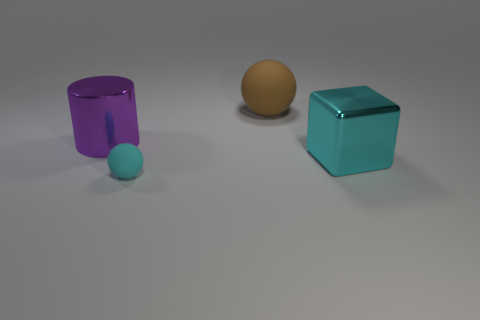Subtract all cylinders. How many objects are left? 3 Add 1 purple cylinders. How many objects exist? 5 Subtract all brown spheres. How many spheres are left? 1 Subtract 1 balls. How many balls are left? 1 Subtract all small brown balls. Subtract all big cylinders. How many objects are left? 3 Add 1 brown things. How many brown things are left? 2 Add 2 brown matte balls. How many brown matte balls exist? 3 Subtract 0 green cylinders. How many objects are left? 4 Subtract all gray spheres. Subtract all blue cubes. How many spheres are left? 2 Subtract all cyan cylinders. How many green blocks are left? 0 